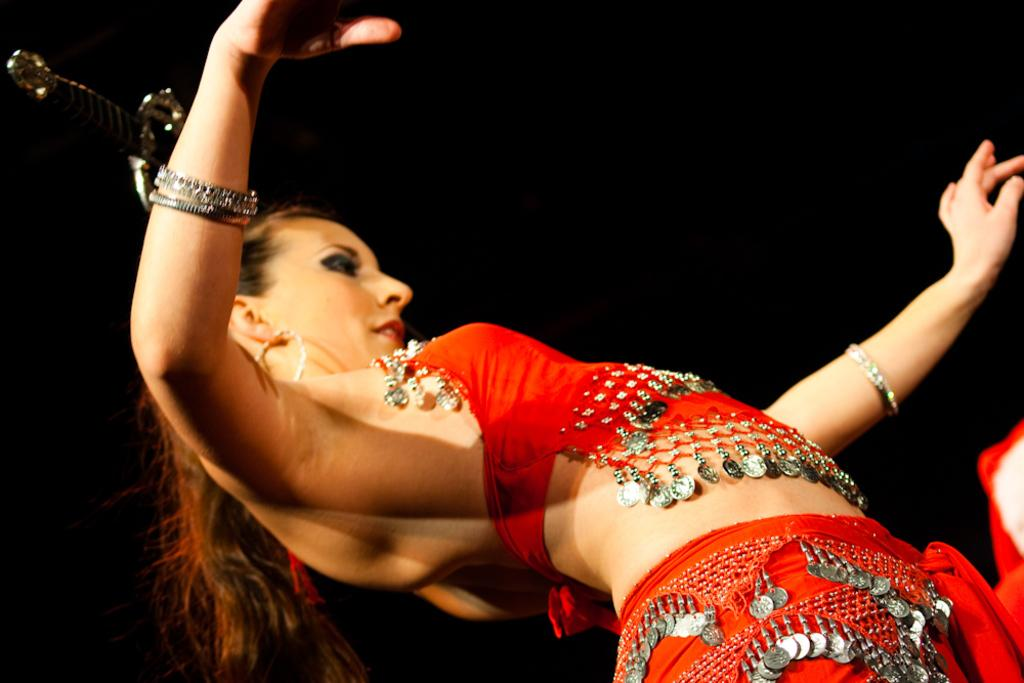What is the main subject of the image? The main subject of the image is a woman. What is the woman wearing in the image? The woman is wearing a red dress in the image. What color is the background of the image? The background of the image is black. What shape is the hot square in the image? There is no hot square present in the image. 